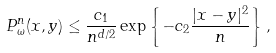Convert formula to latex. <formula><loc_0><loc_0><loc_500><loc_500>P ^ { n } _ { \omega } ( x , y ) \leq \frac { c _ { 1 } } { n ^ { d / 2 } } \exp \left \{ - c _ { 2 } \frac { | x - y | ^ { 2 } } { n } \right \} ,</formula> 